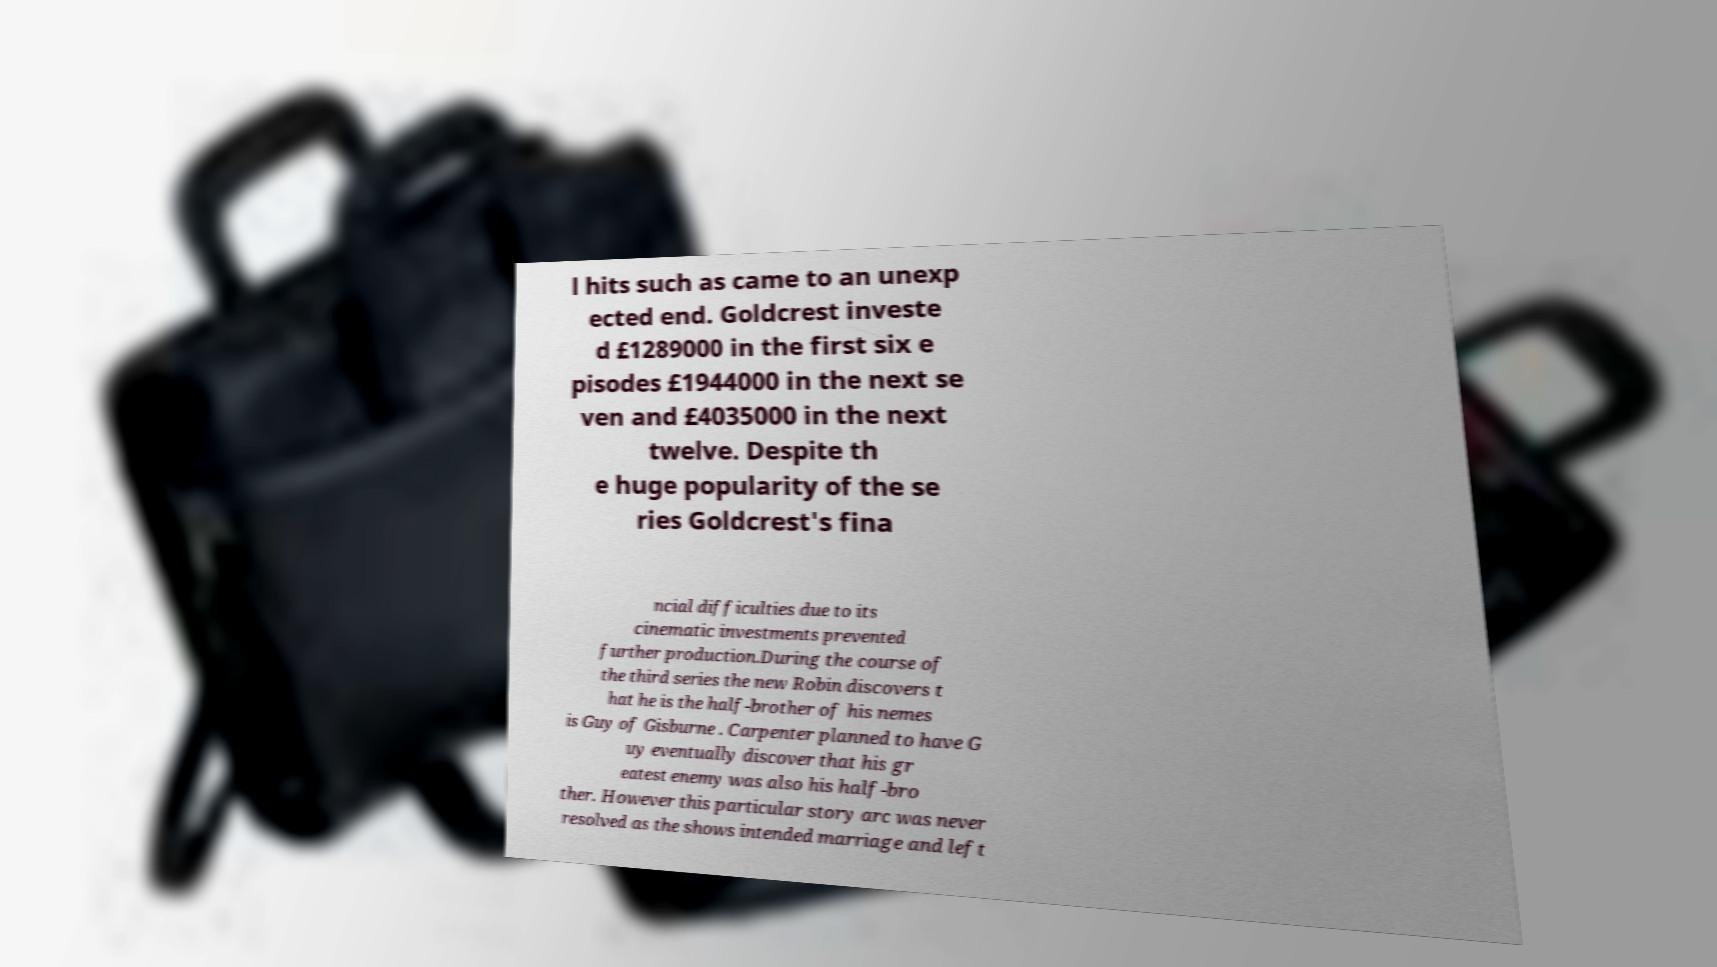Could you assist in decoding the text presented in this image and type it out clearly? l hits such as came to an unexp ected end. Goldcrest investe d £1289000 in the first six e pisodes £1944000 in the next se ven and £4035000 in the next twelve. Despite th e huge popularity of the se ries Goldcrest's fina ncial difficulties due to its cinematic investments prevented further production.During the course of the third series the new Robin discovers t hat he is the half-brother of his nemes is Guy of Gisburne . Carpenter planned to have G uy eventually discover that his gr eatest enemy was also his half-bro ther. However this particular story arc was never resolved as the shows intended marriage and left 